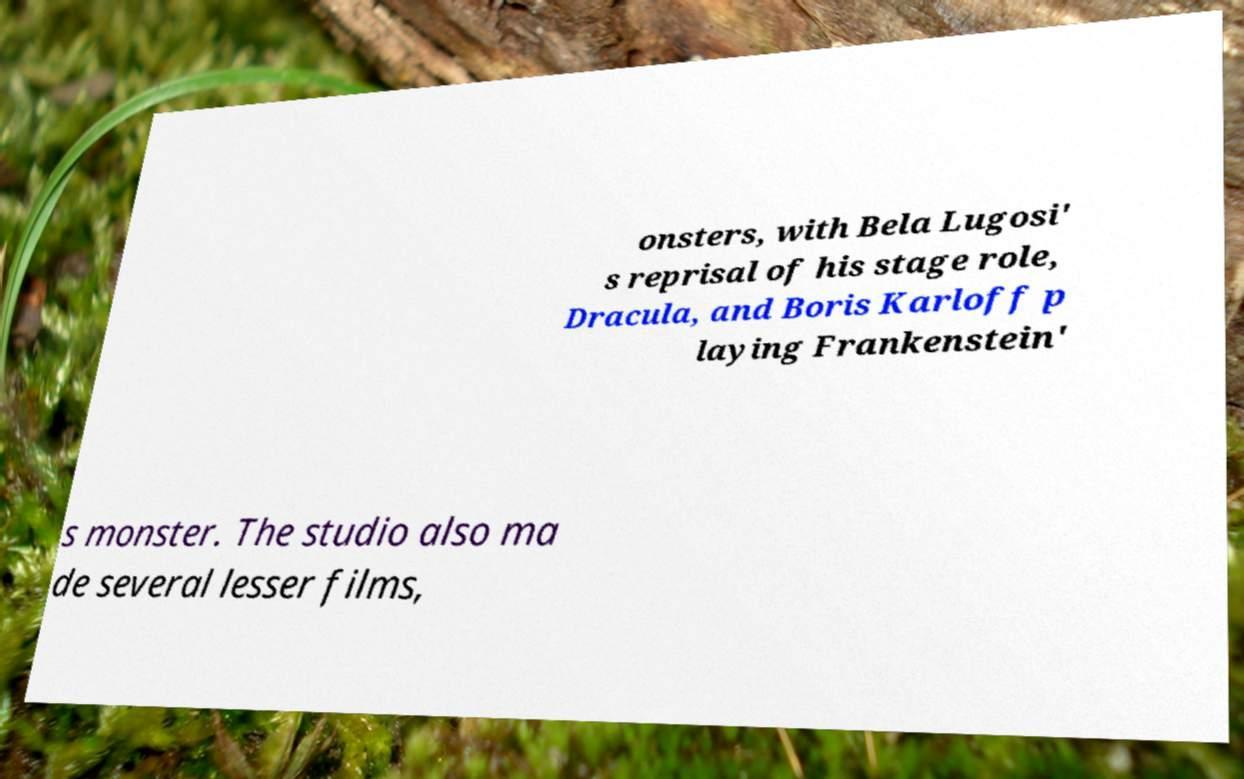Could you assist in decoding the text presented in this image and type it out clearly? onsters, with Bela Lugosi' s reprisal of his stage role, Dracula, and Boris Karloff p laying Frankenstein' s monster. The studio also ma de several lesser films, 